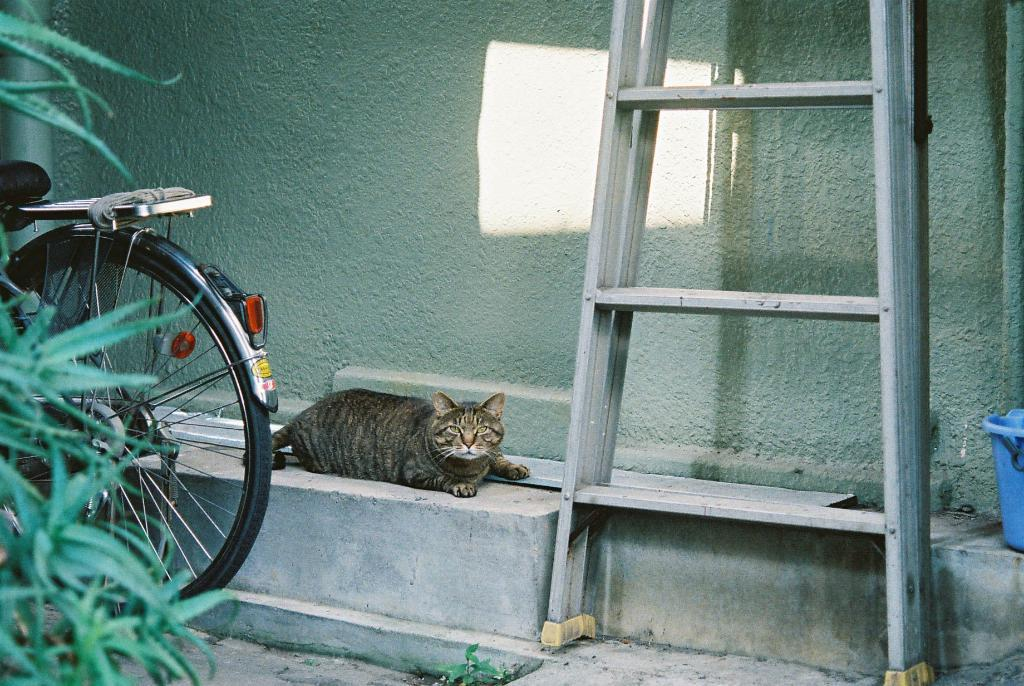What animal can be seen in the image? There is a cat in the image. Where is the cat positioned? The cat is lying on a cement bench. What is behind the cat? There is a wall behind the cat. What objects are in front of the wall? There is a ladder, a cycle, and plants in front of the wall. What time of day is depicted in the image? The provided facts do not mention the time of day, so it cannot be determined from the image. 